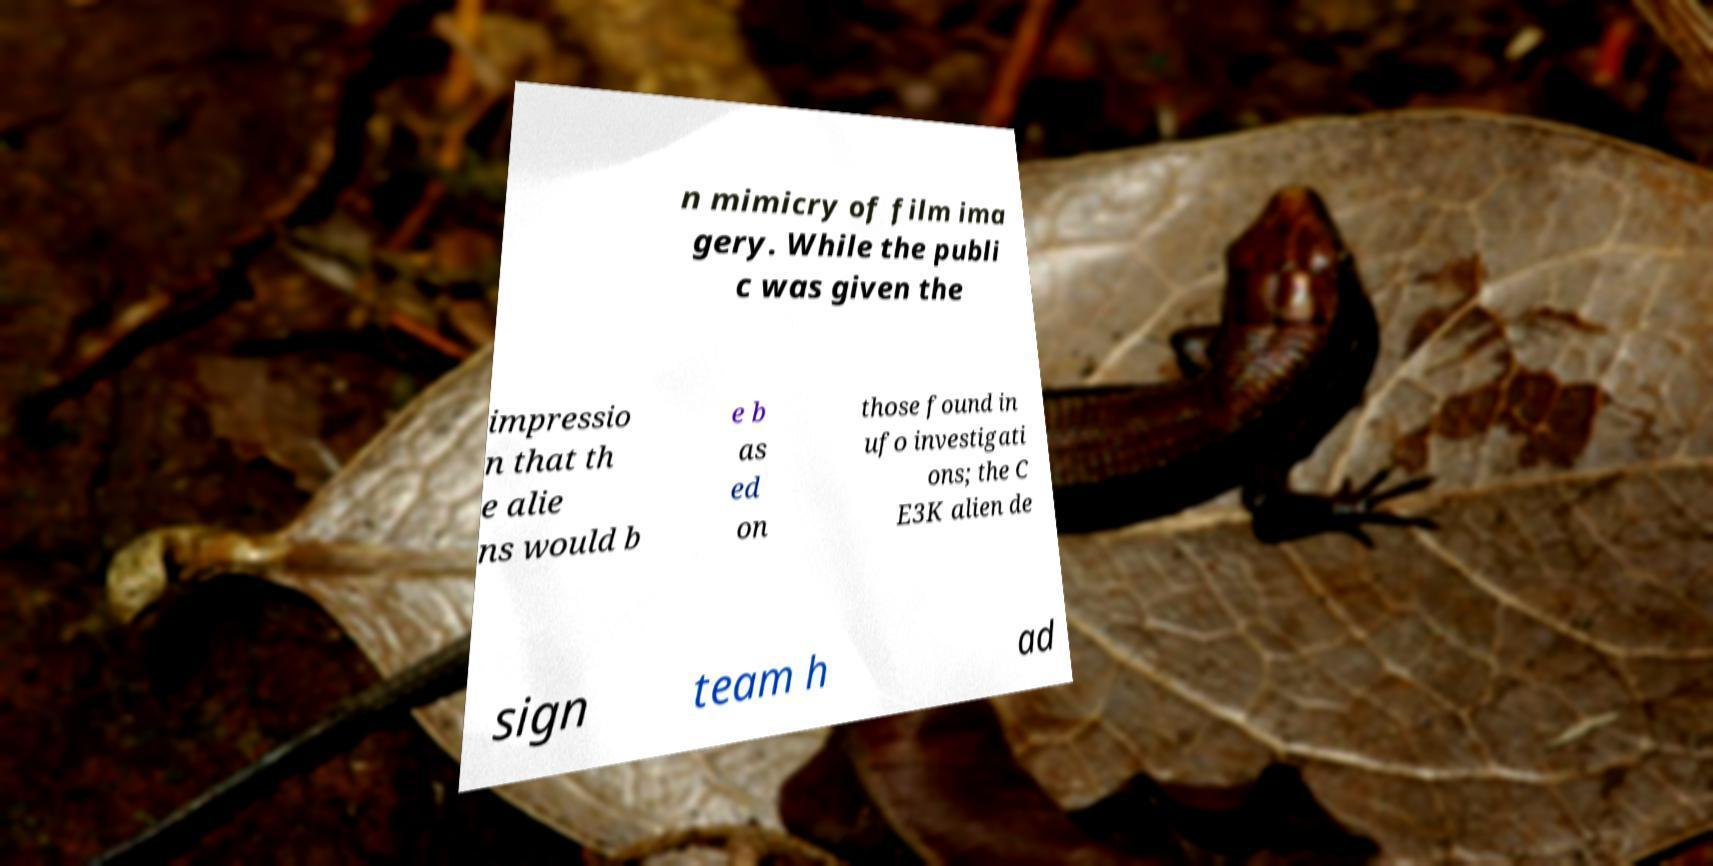I need the written content from this picture converted into text. Can you do that? n mimicry of film ima gery. While the publi c was given the impressio n that th e alie ns would b e b as ed on those found in ufo investigati ons; the C E3K alien de sign team h ad 